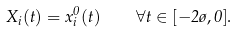<formula> <loc_0><loc_0><loc_500><loc_500>X _ { i } ( t ) = x _ { i } ^ { 0 } ( t ) \quad \forall t \in [ - 2 \tau , 0 ] .</formula> 